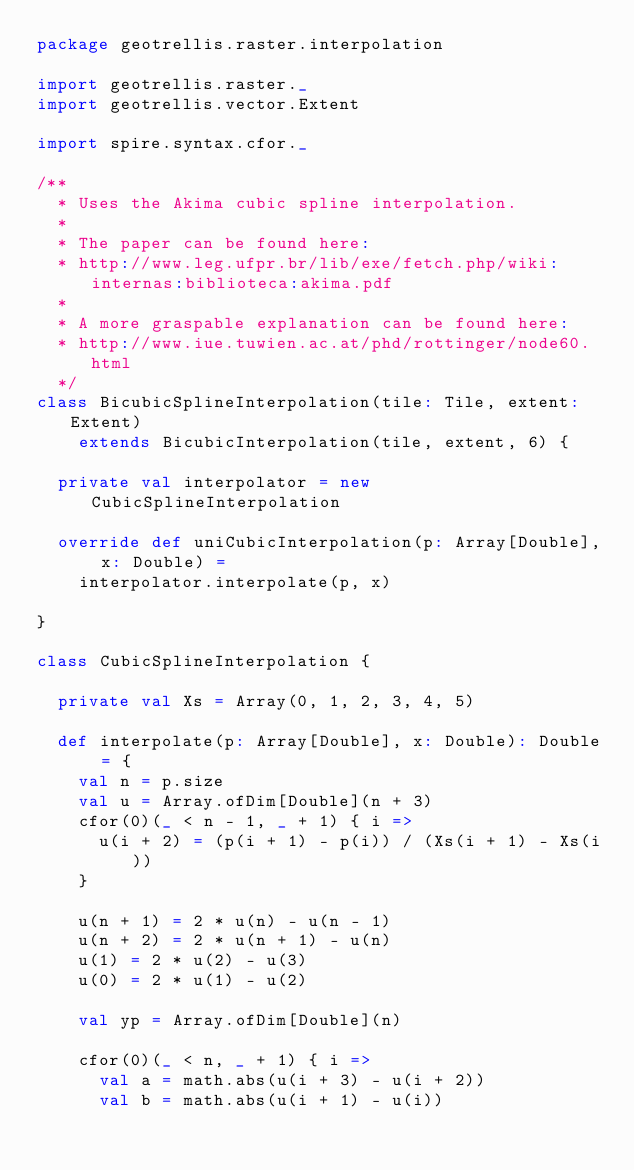Convert code to text. <code><loc_0><loc_0><loc_500><loc_500><_Scala_>package geotrellis.raster.interpolation

import geotrellis.raster._
import geotrellis.vector.Extent

import spire.syntax.cfor._

/**
  * Uses the Akima cubic spline interpolation.
  *
  * The paper can be found here:
  * http://www.leg.ufpr.br/lib/exe/fetch.php/wiki:internas:biblioteca:akima.pdf
  *
  * A more graspable explanation can be found here:
  * http://www.iue.tuwien.ac.at/phd/rottinger/node60.html
  */
class BicubicSplineInterpolation(tile: Tile, extent: Extent)
    extends BicubicInterpolation(tile, extent, 6) {

  private val interpolator = new CubicSplineInterpolation

  override def uniCubicInterpolation(p: Array[Double], x: Double) =
    interpolator.interpolate(p, x)

}

class CubicSplineInterpolation {

  private val Xs = Array(0, 1, 2, 3, 4, 5)

  def interpolate(p: Array[Double], x: Double): Double = {
    val n = p.size
    val u = Array.ofDim[Double](n + 3)
    cfor(0)(_ < n - 1, _ + 1) { i =>
      u(i + 2) = (p(i + 1) - p(i)) / (Xs(i + 1) - Xs(i))
    }

    u(n + 1) = 2 * u(n) - u(n - 1)
    u(n + 2) = 2 * u(n + 1) - u(n)
    u(1) = 2 * u(2) - u(3)
    u(0) = 2 * u(1) - u(2)

    val yp = Array.ofDim[Double](n)

    cfor(0)(_ < n, _ + 1) { i =>
      val a = math.abs(u(i + 3) - u(i + 2))
      val b = math.abs(u(i + 1) - u(i))
</code> 